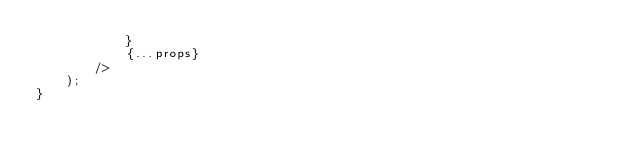Convert code to text. <code><loc_0><loc_0><loc_500><loc_500><_JavaScript_>            }
            {...props}
        />
    );
}</code> 